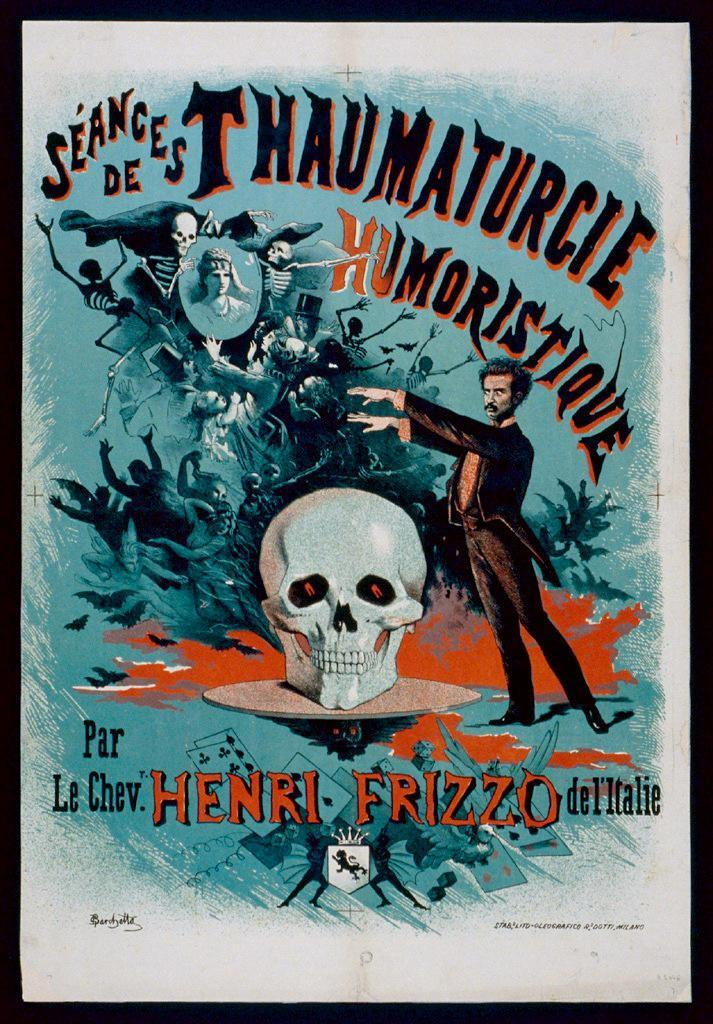<image>
Present a compact description of the photo's key features. A poster for Seances de Thaumaturcie Humoristique with a skull on it. 